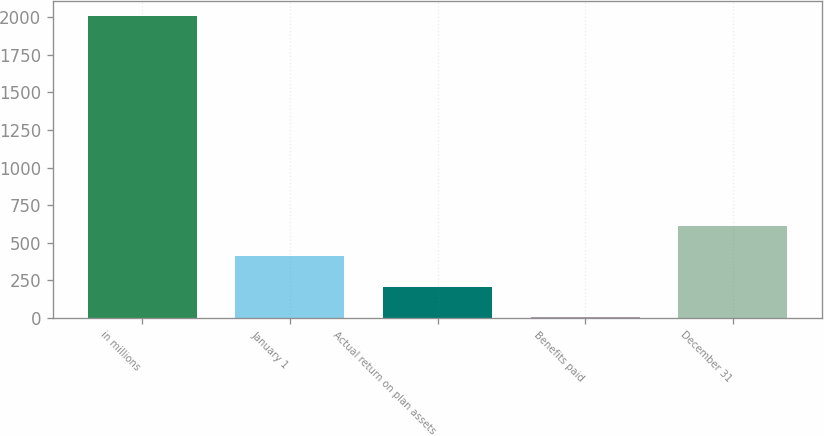<chart> <loc_0><loc_0><loc_500><loc_500><bar_chart><fcel>in millions<fcel>January 1<fcel>Actual return on plan assets<fcel>Benefits paid<fcel>December 31<nl><fcel>2010<fcel>409.36<fcel>209.28<fcel>9.2<fcel>609.44<nl></chart> 